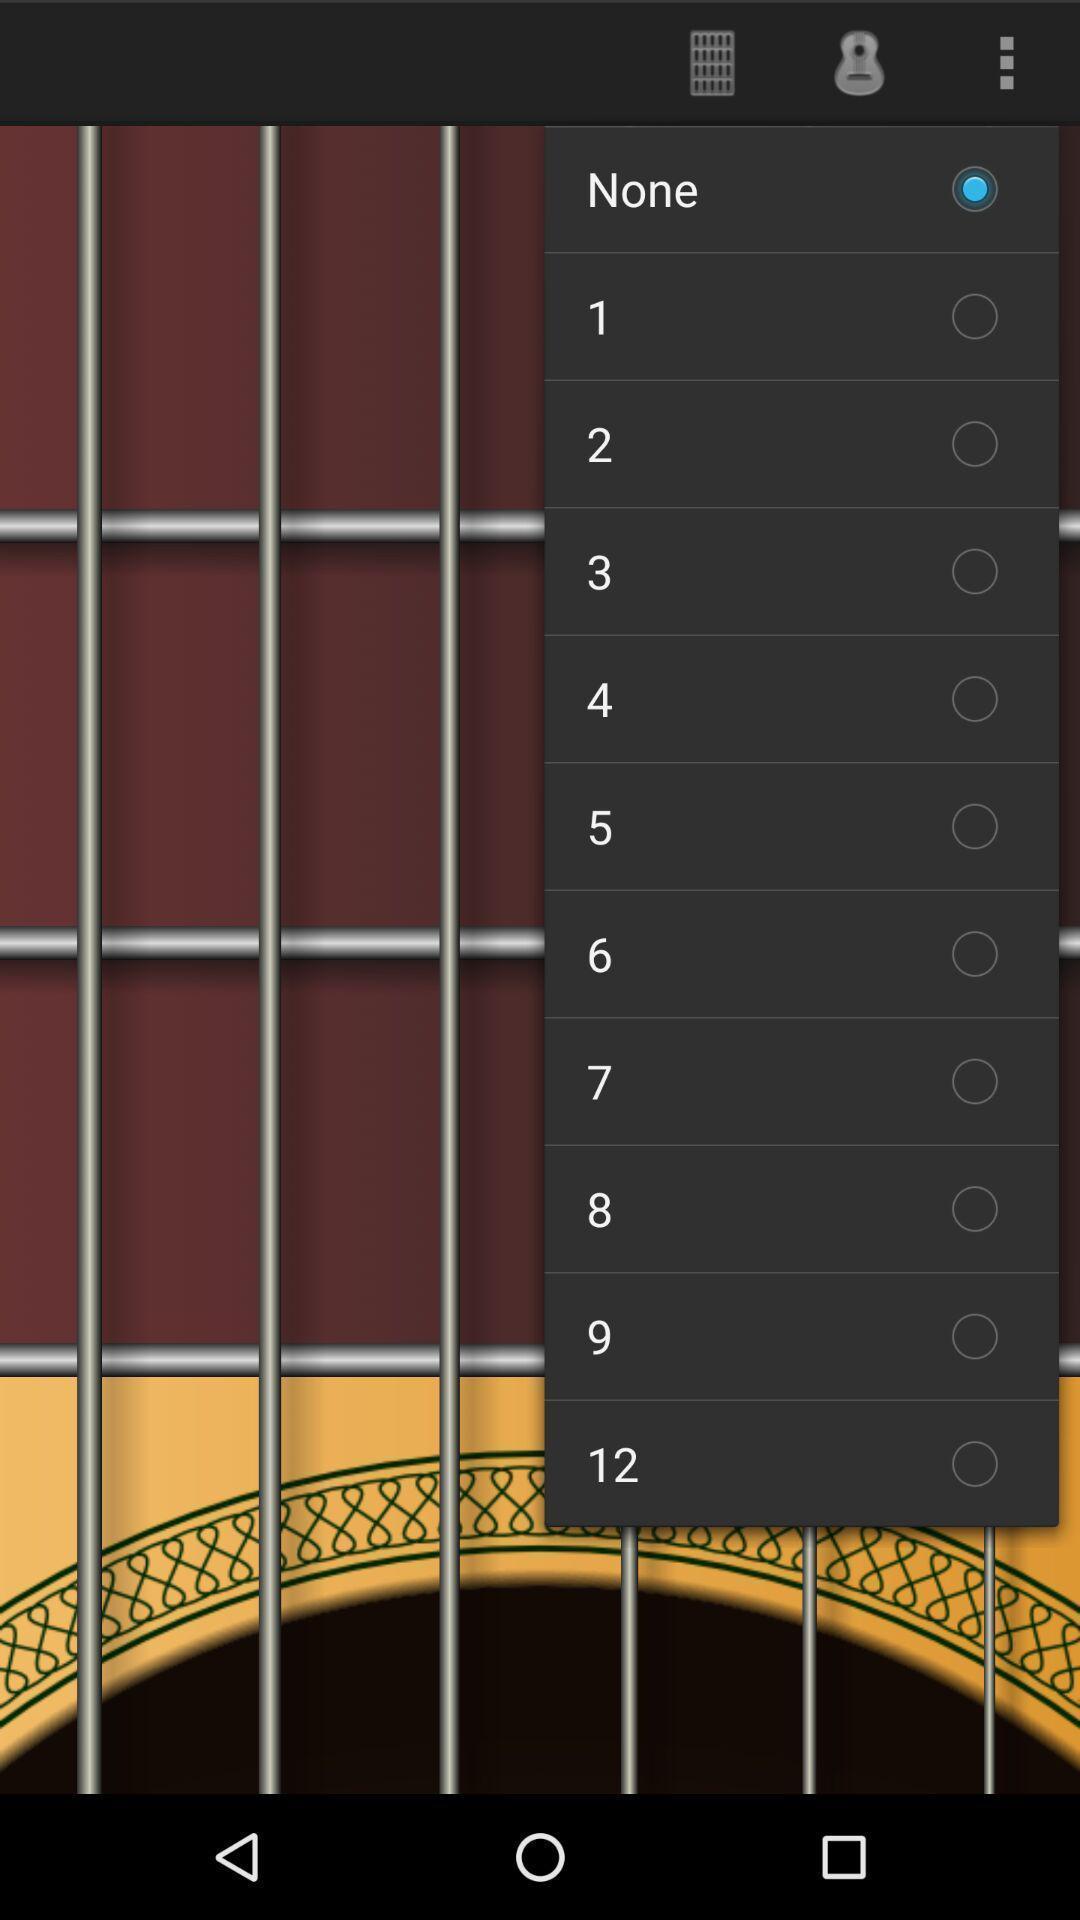Provide a detailed account of this screenshot. Pop up showing options to select on a learning app. 